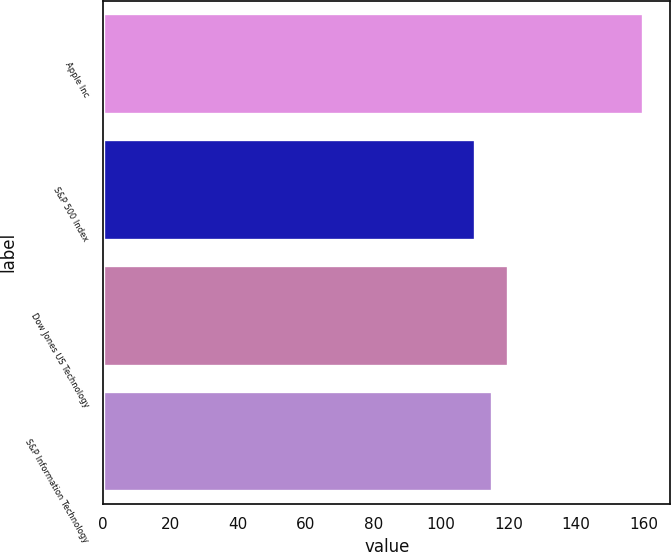Convert chart. <chart><loc_0><loc_0><loc_500><loc_500><bar_chart><fcel>Apple Inc<fcel>S&P 500 Index<fcel>Dow Jones US Technology<fcel>S&P Information Technology<nl><fcel>160<fcel>110<fcel>120<fcel>115<nl></chart> 